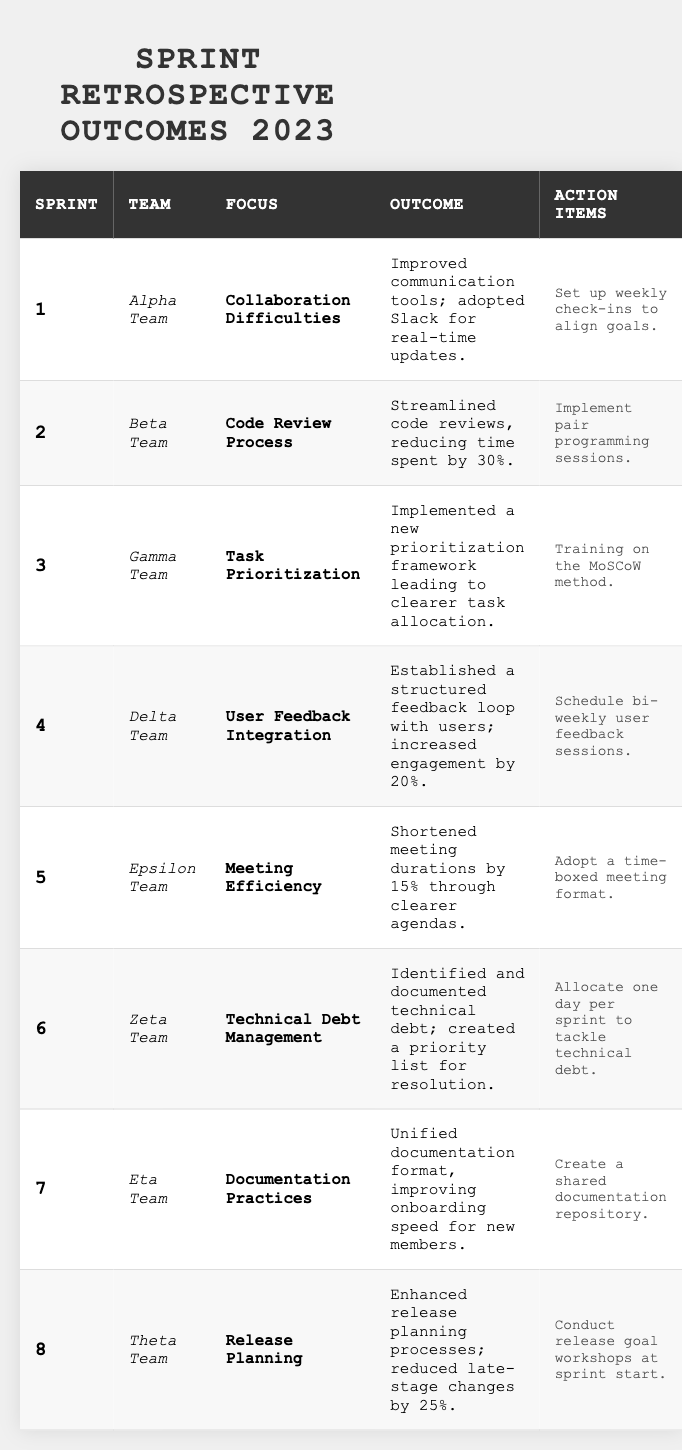What was the retrospective focus for Sprint 3? According to the table, the retrospective focus for Sprint 3 is listed as "Task Prioritization."
Answer: Task Prioritization Which team streamlined their code review process in Sprint 2? From the table, Sprint 2 indicates that the Beta Team streamlined their code review process.
Answer: Beta Team How much time was reduced in code reviews for Sprint 2? The table states that code reviews were streamlined, leading to a time reduction of 30%.
Answer: 30% What action item did the Alpha Team plan to address their retrospective outcome? The action items for the Alpha Team, as mentioned in the table, include setting up weekly check-ins to align goals.
Answer: Set up weekly check-ins Which team implemented a prioritization framework, and what was the outcome? The Gamma Team implemented a new prioritization framework, leading to clearer task allocation, as shown in Sprint 3 of the table.
Answer: Gamma Team; clearer task allocation What is the outcome of the retrospective focus on User Feedback Integration for Sprint 4? For Sprint 4, the outcome was the establishment of a structured feedback loop with users, which increased engagement by 20%.
Answer: Increased engagement by 20% How many sprint teams had a focus on improving documentation practices? According to the table, only one team, the Eta Team, focused on documentation practices in Sprint 7.
Answer: One team Calculate the total number of teams that had a focus on task allocation or prioritization. The Gamma Team focused on Task Prioritization (Sprint 3). Thus, the total is 1 team focusing on task allocation or prioritization.
Answer: 1 team Was there an action item related to technical debt management, and if so, what was it? The Zeta Team identified technical debt and planned to allocate one day per sprint to tackle it, as stated in Sprint 6 of the table.
Answer: Yes, allocate one day per sprint Which team reduced late-stage changes by 25% during release planning? The Theta Team is noted in Sprint 8 for enhancing release planning processes that reduced late-stage changes by 25%.
Answer: Theta Team What common area of focus did multiple teams share in their retrospective meetings? Multiple teams focused on efficiency aspects, including meeting efficiency by Epsilon Team and code review process by Beta Team, reflecting a shared focus on streamlining processes.
Answer: Efficiency 